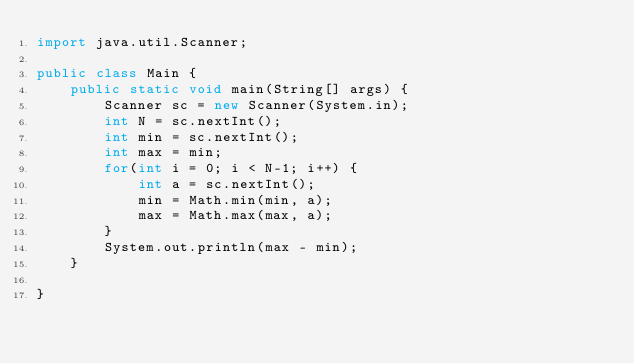Convert code to text. <code><loc_0><loc_0><loc_500><loc_500><_Java_>import java.util.Scanner;

public class Main {
	public static void main(String[] args) {
		Scanner sc = new Scanner(System.in);
		int N = sc.nextInt();
		int min = sc.nextInt();
		int max = min;
		for(int i = 0; i < N-1; i++) {
			int a = sc.nextInt();
			min = Math.min(min, a);
			max = Math.max(max, a);
		}
		System.out.println(max - min);
	}

}
</code> 